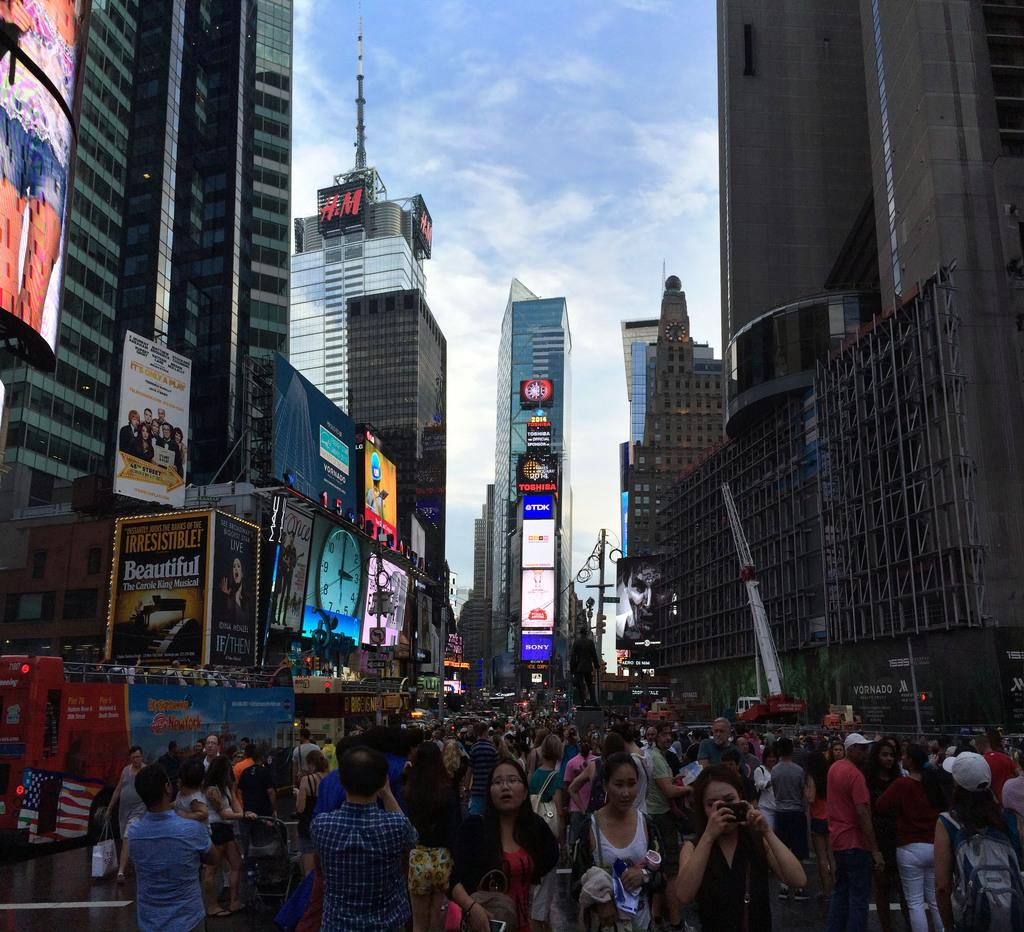<image>
Provide a brief description of the given image. The company H.M. has a big logo posted in time square. 